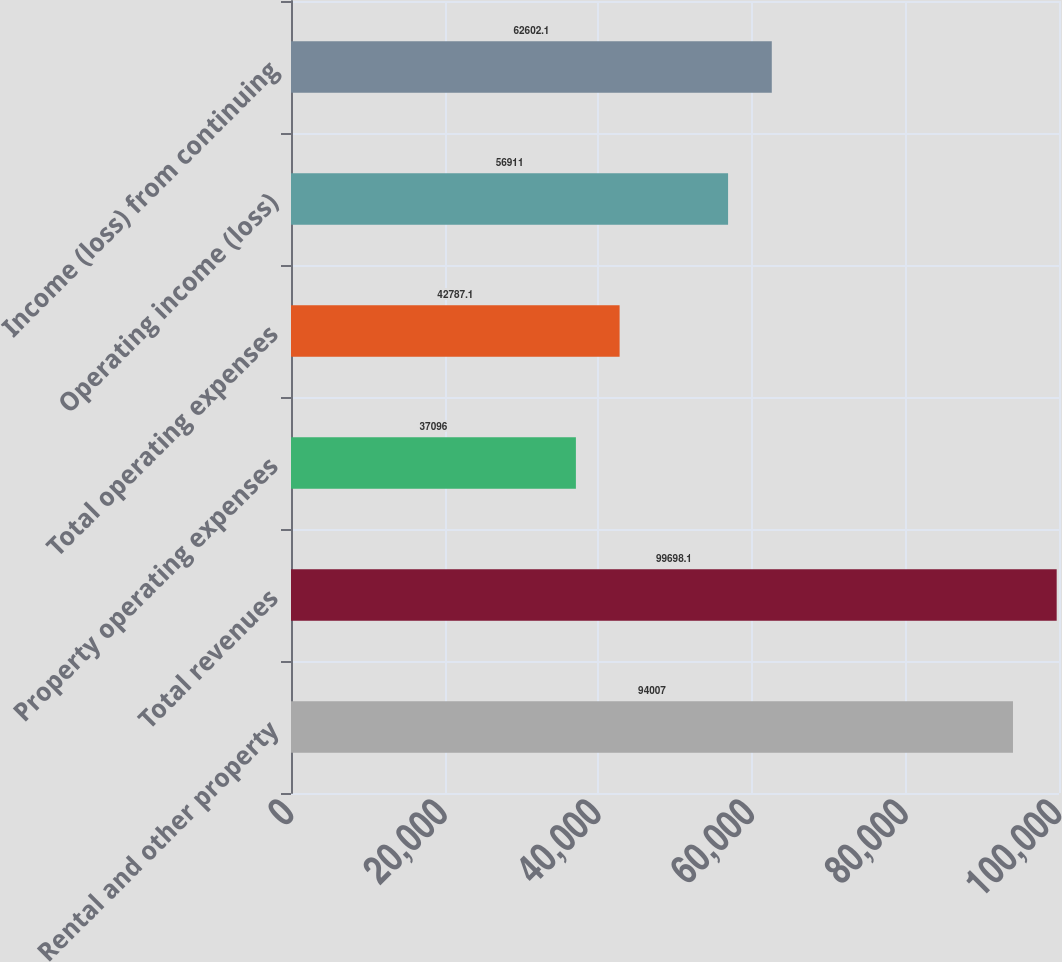Convert chart to OTSL. <chart><loc_0><loc_0><loc_500><loc_500><bar_chart><fcel>Rental and other property<fcel>Total revenues<fcel>Property operating expenses<fcel>Total operating expenses<fcel>Operating income (loss)<fcel>Income (loss) from continuing<nl><fcel>94007<fcel>99698.1<fcel>37096<fcel>42787.1<fcel>56911<fcel>62602.1<nl></chart> 